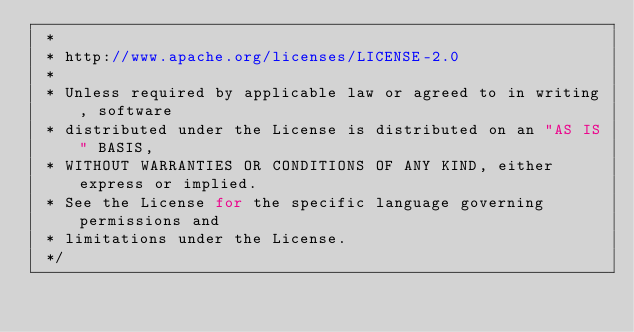Convert code to text. <code><loc_0><loc_0><loc_500><loc_500><_Java_> *
 * http://www.apache.org/licenses/LICENSE-2.0
 *
 * Unless required by applicable law or agreed to in writing, software
 * distributed under the License is distributed on an "AS IS" BASIS,
 * WITHOUT WARRANTIES OR CONDITIONS OF ANY KIND, either express or implied.
 * See the License for the specific language governing permissions and
 * limitations under the License.
 */
</code> 